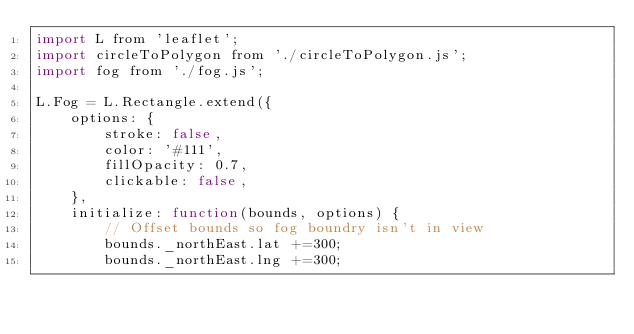Convert code to text. <code><loc_0><loc_0><loc_500><loc_500><_JavaScript_>import L from 'leaflet';
import circleToPolygon from './circleToPolygon.js';
import fog from './fog.js';

L.Fog = L.Rectangle.extend({
    options: {
        stroke: false,
        color: '#111',
        fillOpacity: 0.7,
        clickable: false,
    },
    initialize: function(bounds, options) {
        // Offset bounds so fog boundry isn't in view
        bounds._northEast.lat +=300;
        bounds._northEast.lng +=300;</code> 